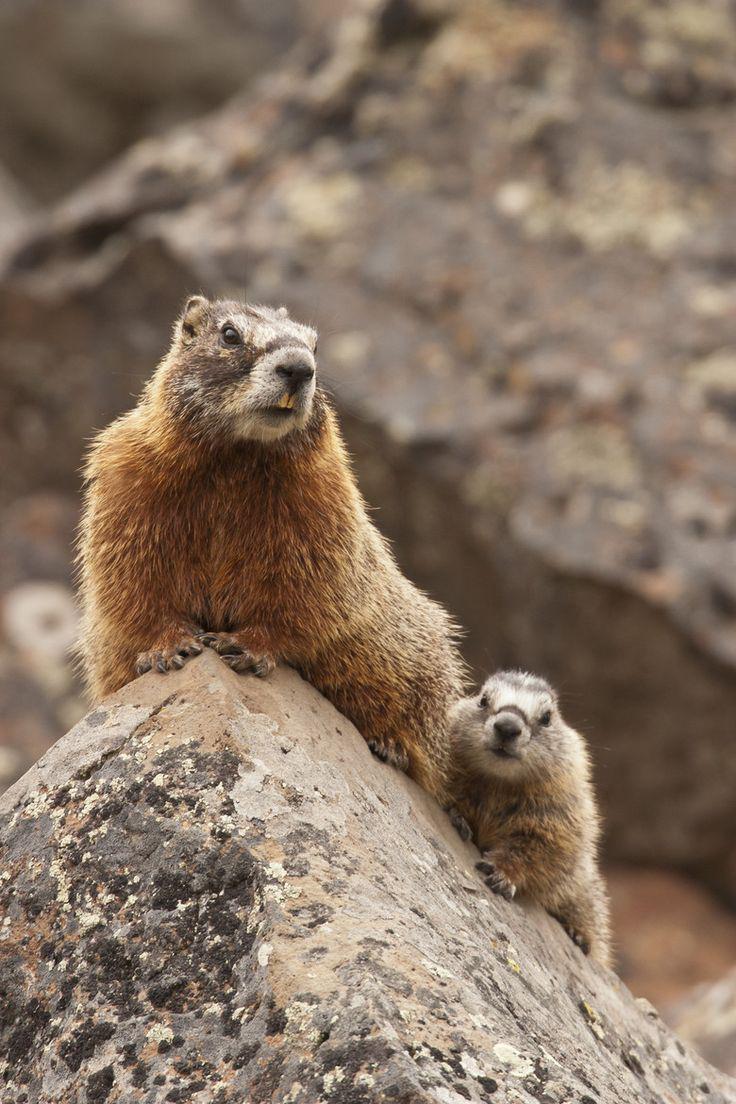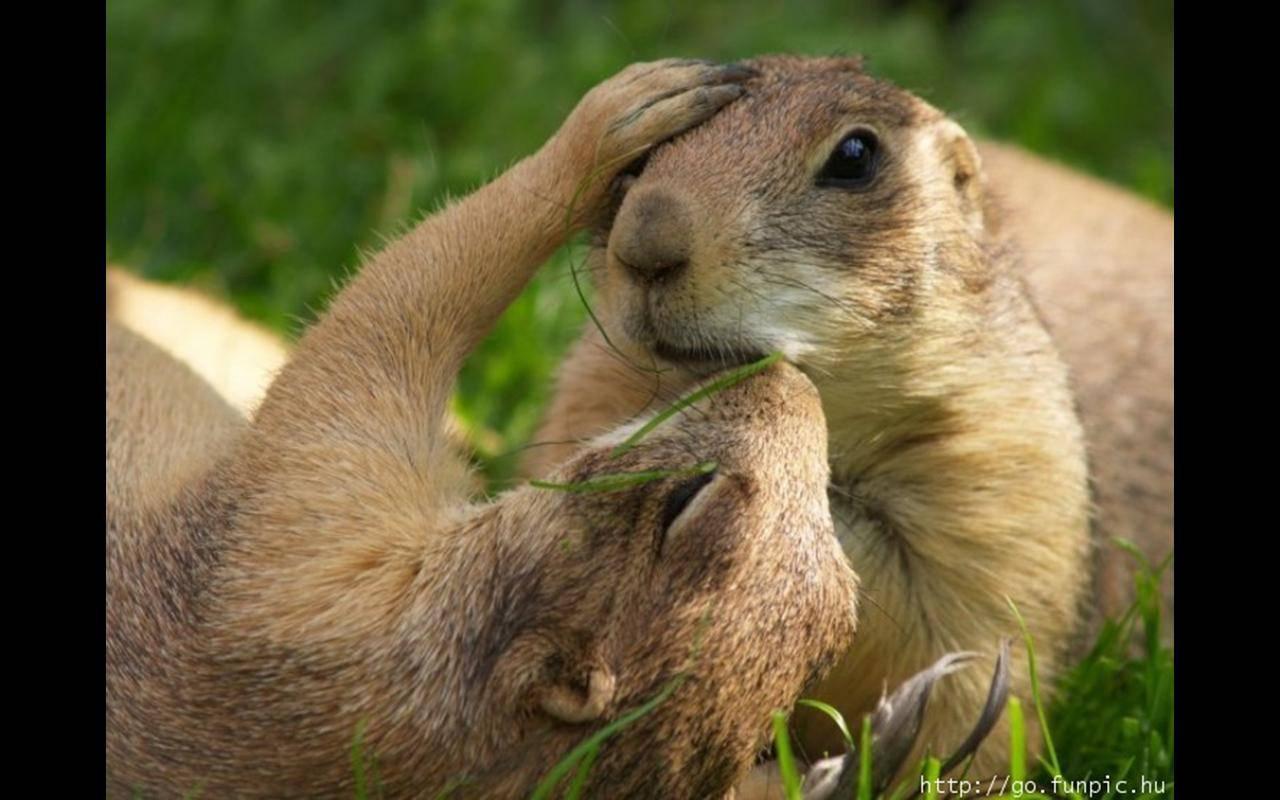The first image is the image on the left, the second image is the image on the right. Considering the images on both sides, is "There is at least one prairie dog standing on its hind legs." valid? Answer yes or no. No. 